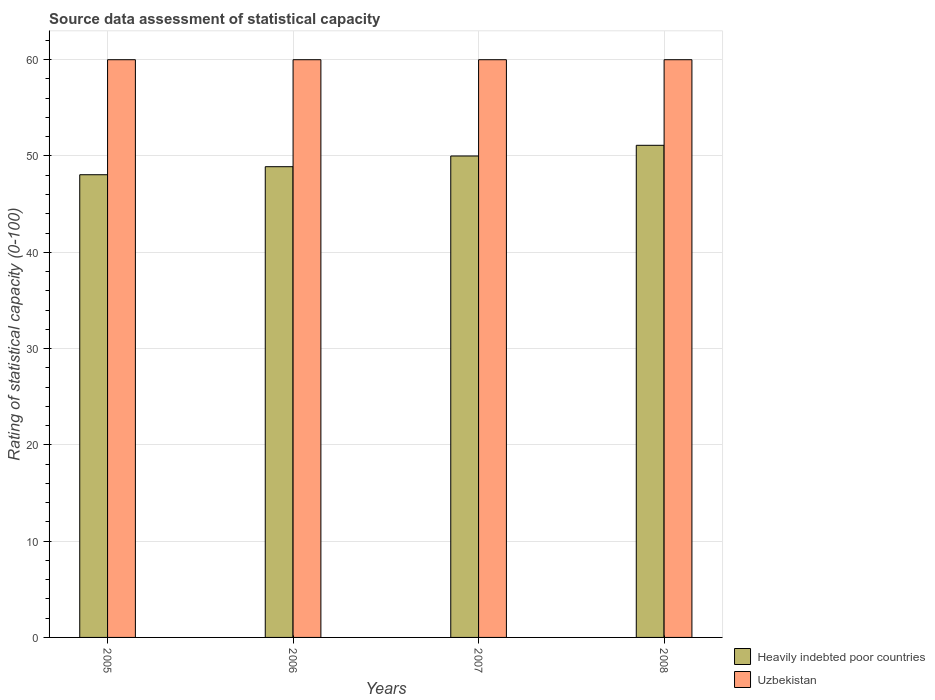How many bars are there on the 3rd tick from the left?
Give a very brief answer. 2. In how many cases, is the number of bars for a given year not equal to the number of legend labels?
Provide a short and direct response. 0. What is the rating of statistical capacity in Uzbekistan in 2007?
Your answer should be compact. 60. Across all years, what is the maximum rating of statistical capacity in Heavily indebted poor countries?
Provide a succinct answer. 51.11. Across all years, what is the minimum rating of statistical capacity in Uzbekistan?
Your response must be concise. 60. What is the total rating of statistical capacity in Uzbekistan in the graph?
Provide a short and direct response. 240. What is the difference between the rating of statistical capacity in Heavily indebted poor countries in 2006 and that in 2008?
Make the answer very short. -2.22. What is the average rating of statistical capacity in Heavily indebted poor countries per year?
Your response must be concise. 49.51. In the year 2008, what is the difference between the rating of statistical capacity in Uzbekistan and rating of statistical capacity in Heavily indebted poor countries?
Give a very brief answer. 8.89. In how many years, is the rating of statistical capacity in Uzbekistan greater than 22?
Your answer should be compact. 4. What is the ratio of the rating of statistical capacity in Heavily indebted poor countries in 2006 to that in 2008?
Provide a succinct answer. 0.96. Is the rating of statistical capacity in Heavily indebted poor countries in 2005 less than that in 2006?
Make the answer very short. Yes. What is the difference between the highest and the second highest rating of statistical capacity in Uzbekistan?
Provide a short and direct response. 0. What is the difference between the highest and the lowest rating of statistical capacity in Heavily indebted poor countries?
Ensure brevity in your answer.  3.06. In how many years, is the rating of statistical capacity in Uzbekistan greater than the average rating of statistical capacity in Uzbekistan taken over all years?
Keep it short and to the point. 0. What does the 2nd bar from the left in 2006 represents?
Make the answer very short. Uzbekistan. What does the 2nd bar from the right in 2007 represents?
Your answer should be very brief. Heavily indebted poor countries. How many bars are there?
Your answer should be very brief. 8. Are all the bars in the graph horizontal?
Your response must be concise. No. Are the values on the major ticks of Y-axis written in scientific E-notation?
Your response must be concise. No. Where does the legend appear in the graph?
Keep it short and to the point. Bottom right. What is the title of the graph?
Keep it short and to the point. Source data assessment of statistical capacity. What is the label or title of the Y-axis?
Ensure brevity in your answer.  Rating of statistical capacity (0-100). What is the Rating of statistical capacity (0-100) of Heavily indebted poor countries in 2005?
Provide a succinct answer. 48.06. What is the Rating of statistical capacity (0-100) in Heavily indebted poor countries in 2006?
Offer a terse response. 48.89. What is the Rating of statistical capacity (0-100) of Uzbekistan in 2006?
Keep it short and to the point. 60. What is the Rating of statistical capacity (0-100) in Uzbekistan in 2007?
Ensure brevity in your answer.  60. What is the Rating of statistical capacity (0-100) in Heavily indebted poor countries in 2008?
Give a very brief answer. 51.11. What is the Rating of statistical capacity (0-100) in Uzbekistan in 2008?
Keep it short and to the point. 60. Across all years, what is the maximum Rating of statistical capacity (0-100) of Heavily indebted poor countries?
Offer a terse response. 51.11. Across all years, what is the maximum Rating of statistical capacity (0-100) of Uzbekistan?
Offer a very short reply. 60. Across all years, what is the minimum Rating of statistical capacity (0-100) in Heavily indebted poor countries?
Offer a very short reply. 48.06. What is the total Rating of statistical capacity (0-100) in Heavily indebted poor countries in the graph?
Provide a short and direct response. 198.06. What is the total Rating of statistical capacity (0-100) of Uzbekistan in the graph?
Make the answer very short. 240. What is the difference between the Rating of statistical capacity (0-100) of Heavily indebted poor countries in 2005 and that in 2006?
Your answer should be compact. -0.83. What is the difference between the Rating of statistical capacity (0-100) of Heavily indebted poor countries in 2005 and that in 2007?
Provide a succinct answer. -1.94. What is the difference between the Rating of statistical capacity (0-100) of Heavily indebted poor countries in 2005 and that in 2008?
Offer a terse response. -3.06. What is the difference between the Rating of statistical capacity (0-100) of Heavily indebted poor countries in 2006 and that in 2007?
Your answer should be compact. -1.11. What is the difference between the Rating of statistical capacity (0-100) of Heavily indebted poor countries in 2006 and that in 2008?
Provide a succinct answer. -2.22. What is the difference between the Rating of statistical capacity (0-100) of Uzbekistan in 2006 and that in 2008?
Keep it short and to the point. 0. What is the difference between the Rating of statistical capacity (0-100) in Heavily indebted poor countries in 2007 and that in 2008?
Make the answer very short. -1.11. What is the difference between the Rating of statistical capacity (0-100) of Heavily indebted poor countries in 2005 and the Rating of statistical capacity (0-100) of Uzbekistan in 2006?
Provide a short and direct response. -11.94. What is the difference between the Rating of statistical capacity (0-100) in Heavily indebted poor countries in 2005 and the Rating of statistical capacity (0-100) in Uzbekistan in 2007?
Your answer should be very brief. -11.94. What is the difference between the Rating of statistical capacity (0-100) in Heavily indebted poor countries in 2005 and the Rating of statistical capacity (0-100) in Uzbekistan in 2008?
Make the answer very short. -11.94. What is the difference between the Rating of statistical capacity (0-100) in Heavily indebted poor countries in 2006 and the Rating of statistical capacity (0-100) in Uzbekistan in 2007?
Provide a short and direct response. -11.11. What is the difference between the Rating of statistical capacity (0-100) of Heavily indebted poor countries in 2006 and the Rating of statistical capacity (0-100) of Uzbekistan in 2008?
Give a very brief answer. -11.11. What is the difference between the Rating of statistical capacity (0-100) of Heavily indebted poor countries in 2007 and the Rating of statistical capacity (0-100) of Uzbekistan in 2008?
Offer a very short reply. -10. What is the average Rating of statistical capacity (0-100) of Heavily indebted poor countries per year?
Your answer should be very brief. 49.51. In the year 2005, what is the difference between the Rating of statistical capacity (0-100) of Heavily indebted poor countries and Rating of statistical capacity (0-100) of Uzbekistan?
Keep it short and to the point. -11.94. In the year 2006, what is the difference between the Rating of statistical capacity (0-100) of Heavily indebted poor countries and Rating of statistical capacity (0-100) of Uzbekistan?
Ensure brevity in your answer.  -11.11. In the year 2007, what is the difference between the Rating of statistical capacity (0-100) in Heavily indebted poor countries and Rating of statistical capacity (0-100) in Uzbekistan?
Offer a terse response. -10. In the year 2008, what is the difference between the Rating of statistical capacity (0-100) in Heavily indebted poor countries and Rating of statistical capacity (0-100) in Uzbekistan?
Provide a succinct answer. -8.89. What is the ratio of the Rating of statistical capacity (0-100) in Heavily indebted poor countries in 2005 to that in 2007?
Offer a very short reply. 0.96. What is the ratio of the Rating of statistical capacity (0-100) of Heavily indebted poor countries in 2005 to that in 2008?
Offer a terse response. 0.94. What is the ratio of the Rating of statistical capacity (0-100) in Uzbekistan in 2005 to that in 2008?
Make the answer very short. 1. What is the ratio of the Rating of statistical capacity (0-100) in Heavily indebted poor countries in 2006 to that in 2007?
Offer a terse response. 0.98. What is the ratio of the Rating of statistical capacity (0-100) in Uzbekistan in 2006 to that in 2007?
Your answer should be compact. 1. What is the ratio of the Rating of statistical capacity (0-100) of Heavily indebted poor countries in 2006 to that in 2008?
Offer a terse response. 0.96. What is the ratio of the Rating of statistical capacity (0-100) in Heavily indebted poor countries in 2007 to that in 2008?
Give a very brief answer. 0.98. What is the ratio of the Rating of statistical capacity (0-100) of Uzbekistan in 2007 to that in 2008?
Make the answer very short. 1. What is the difference between the highest and the lowest Rating of statistical capacity (0-100) of Heavily indebted poor countries?
Keep it short and to the point. 3.06. What is the difference between the highest and the lowest Rating of statistical capacity (0-100) of Uzbekistan?
Provide a succinct answer. 0. 